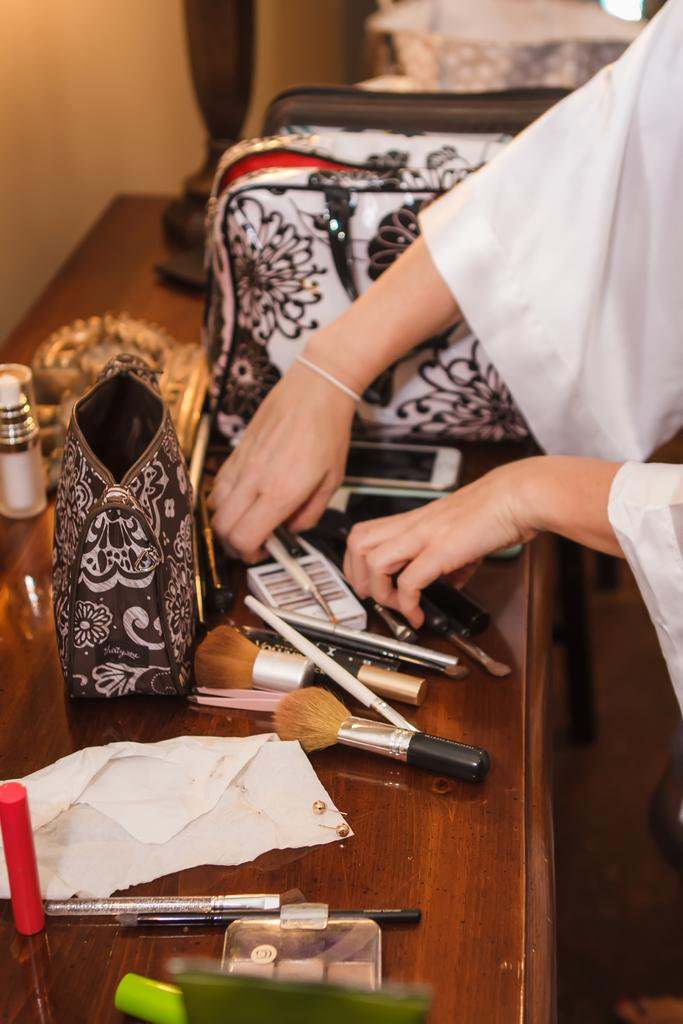What type of tools are on the table in the image? There are makeup brushes on the table. What else can be seen on the table besides the makeup brushes? There are other objects on the table. Can you describe the person in the image? There is a person in the right corner of the image. What type of iron is being used by the person in the image? There is no iron present in the image; the person is not using any ironing tools. 